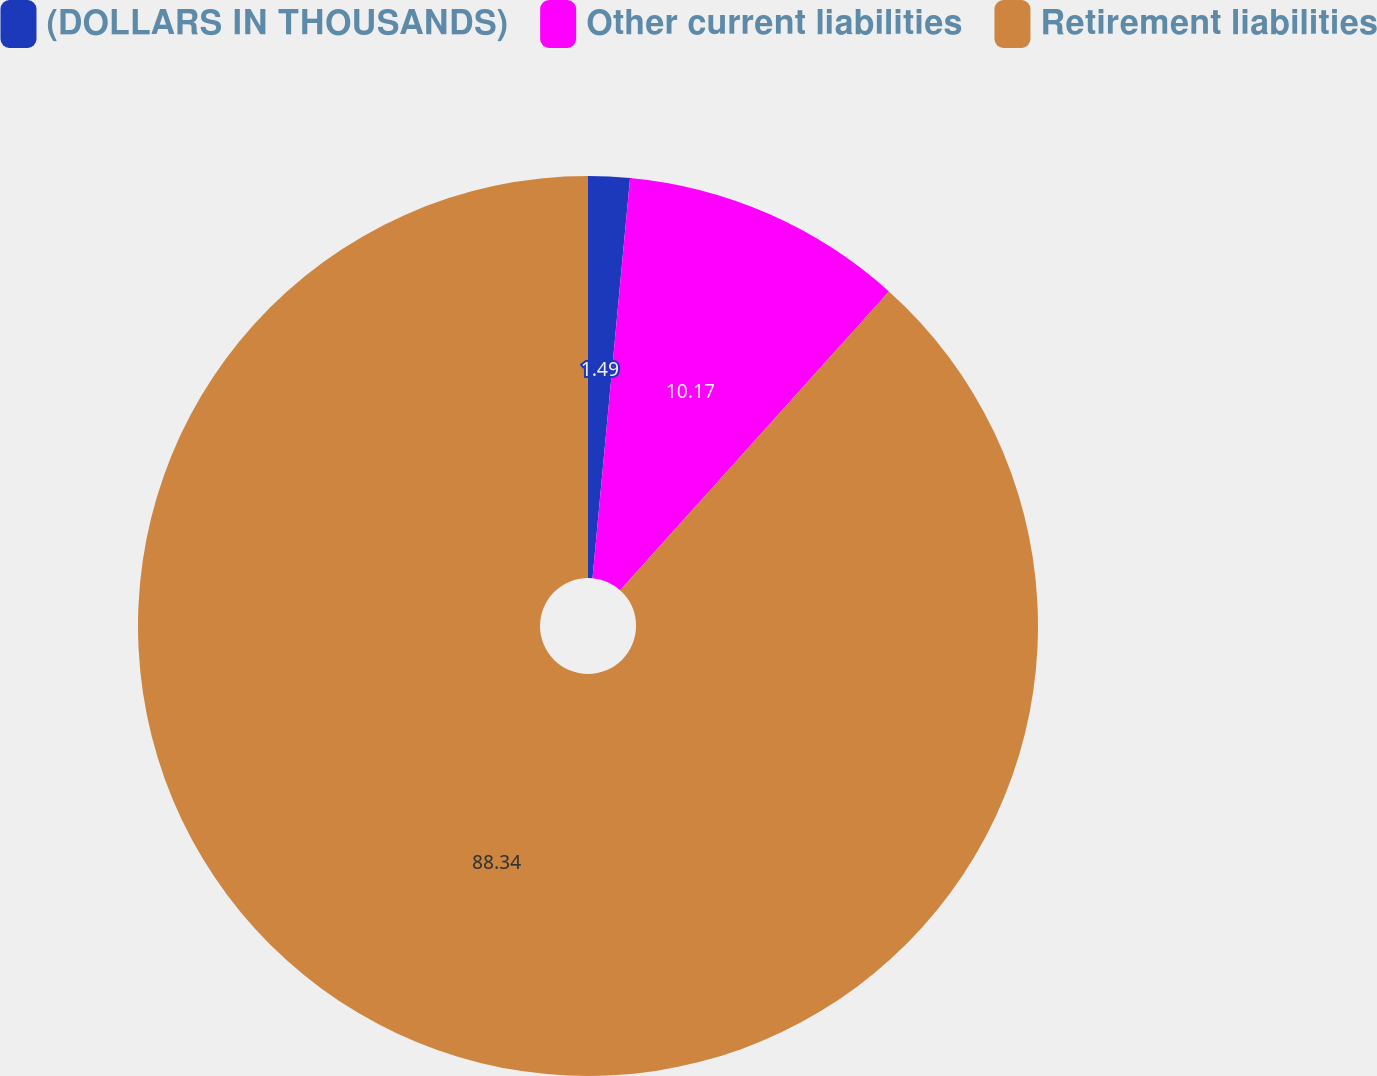Convert chart. <chart><loc_0><loc_0><loc_500><loc_500><pie_chart><fcel>(DOLLARS IN THOUSANDS)<fcel>Other current liabilities<fcel>Retirement liabilities<nl><fcel>1.49%<fcel>10.17%<fcel>88.34%<nl></chart> 